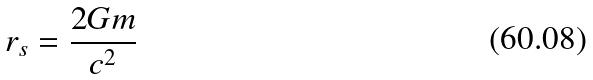<formula> <loc_0><loc_0><loc_500><loc_500>r _ { s } = \frac { 2 G m } { c ^ { 2 } }</formula> 